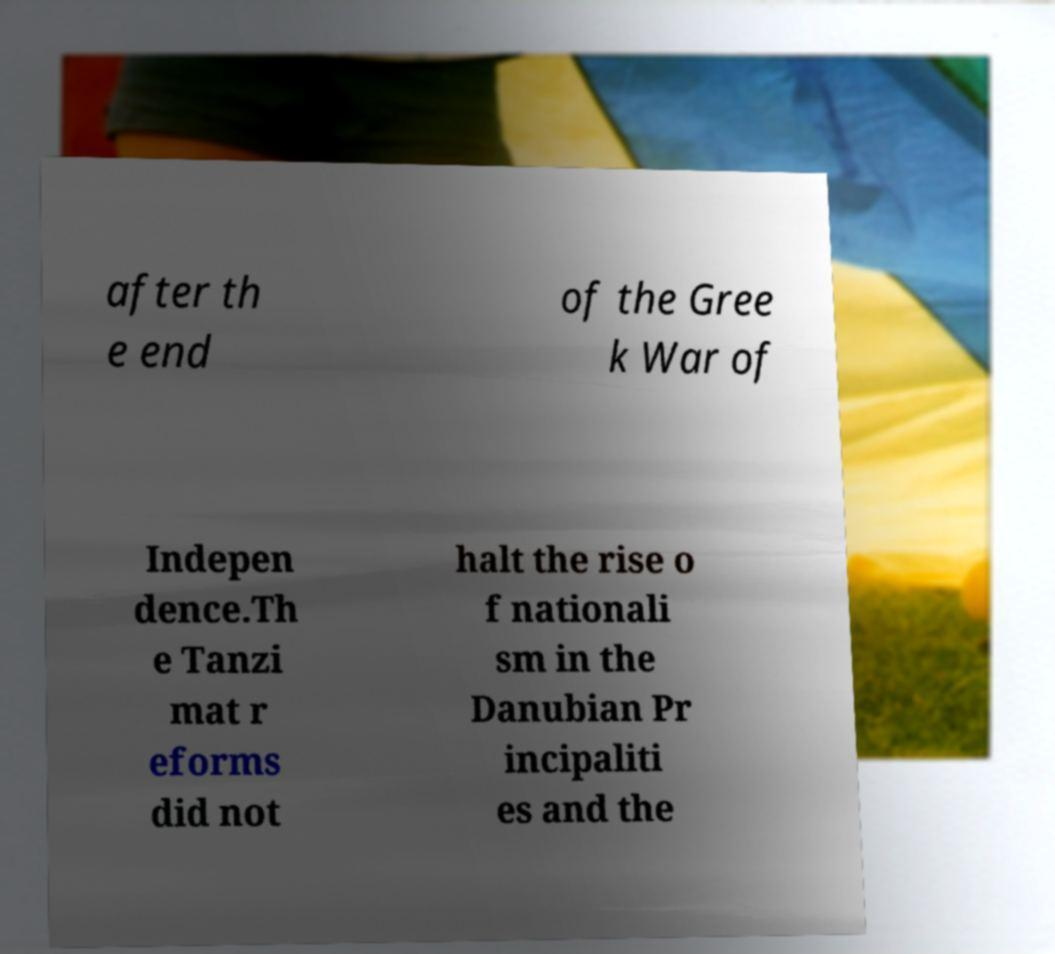For documentation purposes, I need the text within this image transcribed. Could you provide that? after th e end of the Gree k War of Indepen dence.Th e Tanzi mat r eforms did not halt the rise o f nationali sm in the Danubian Pr incipaliti es and the 